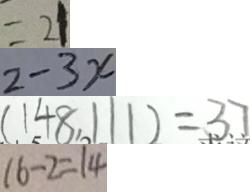<formula> <loc_0><loc_0><loc_500><loc_500>= 2 1 
 2 - 3 x 
 ( 1 4 8 , 1 1 1 ) = 3 7 
 1 6 - 2 = 1 4</formula> 